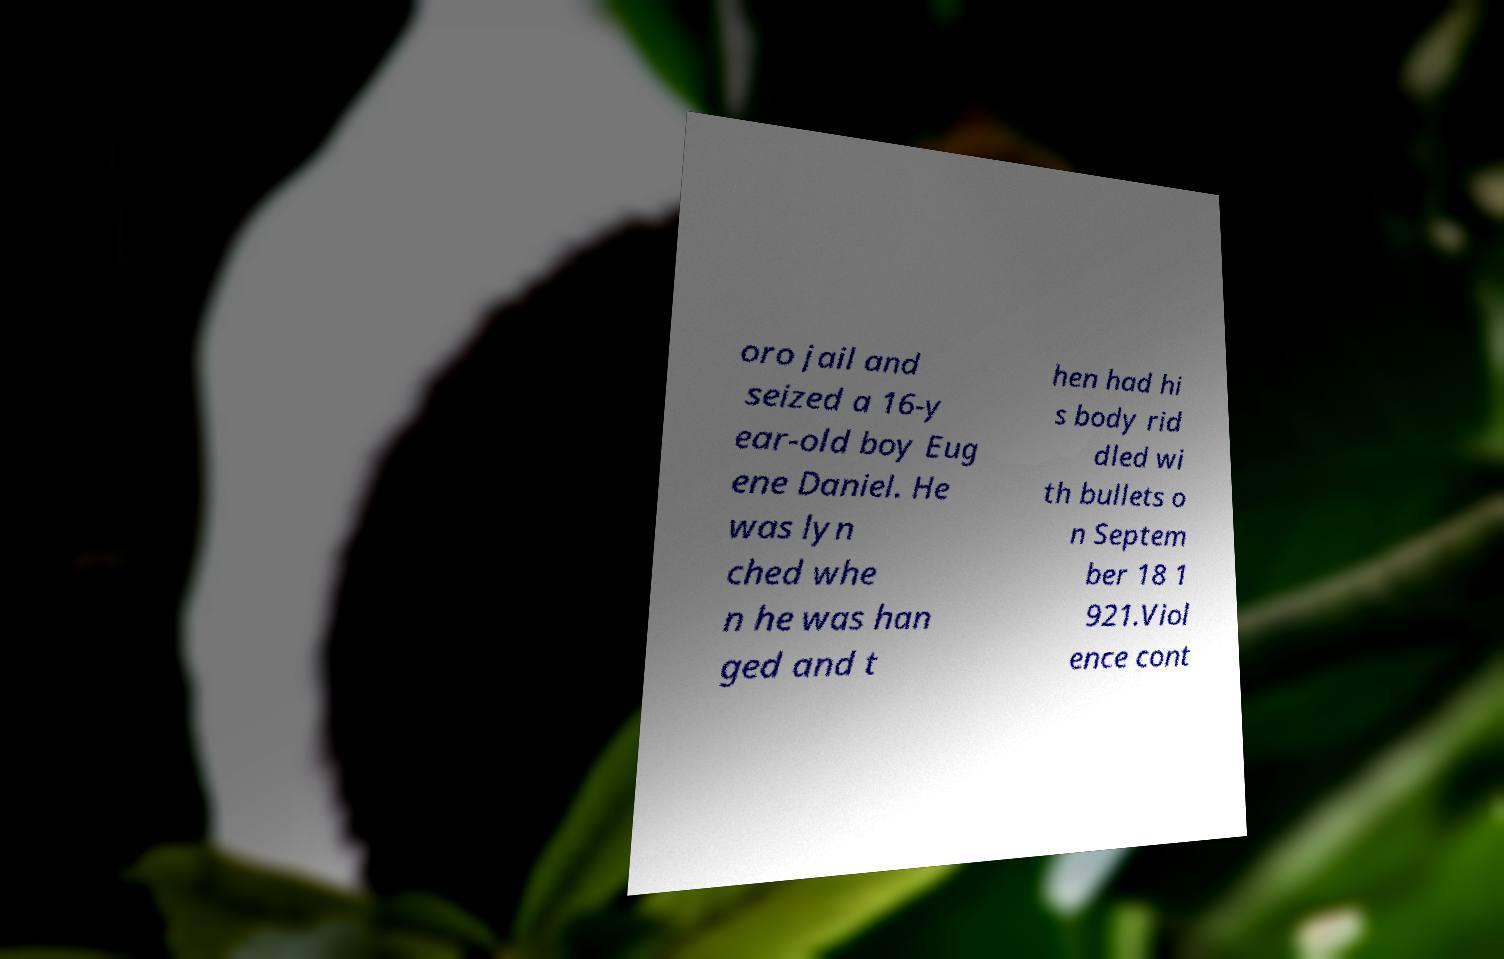Please read and relay the text visible in this image. What does it say? oro jail and seized a 16-y ear-old boy Eug ene Daniel. He was lyn ched whe n he was han ged and t hen had hi s body rid dled wi th bullets o n Septem ber 18 1 921.Viol ence cont 